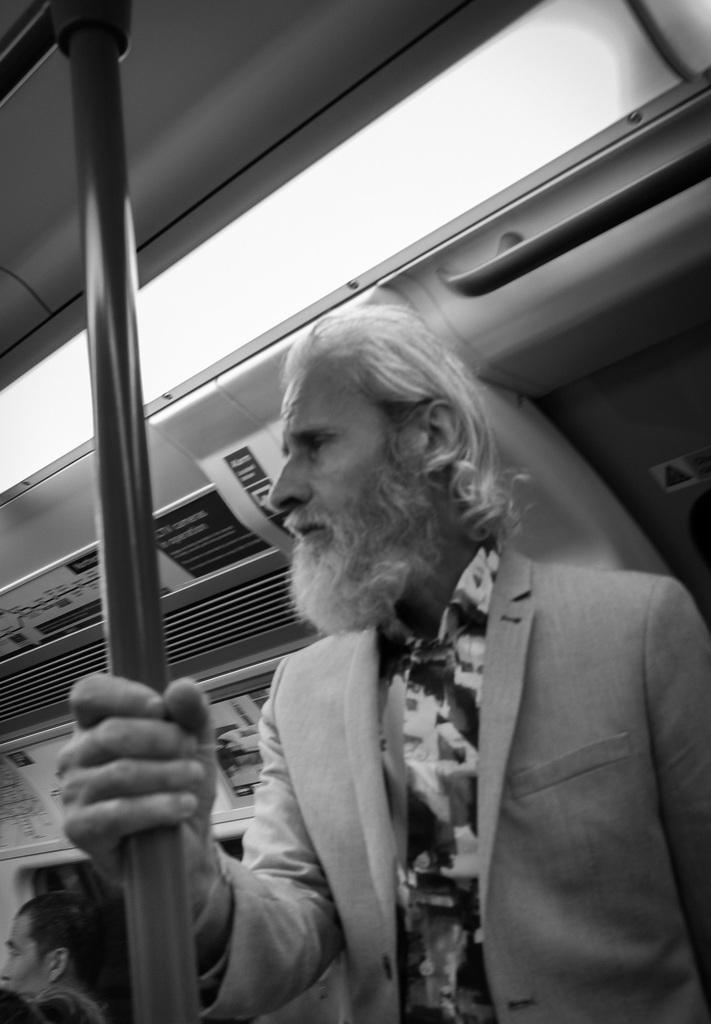Please provide a concise description of this image. This is a black and white pic. This is the inside view of a train. In this image we can see a old man is holding a rod in his hand. In the background there are stickers and light and we can see few persons heads. 